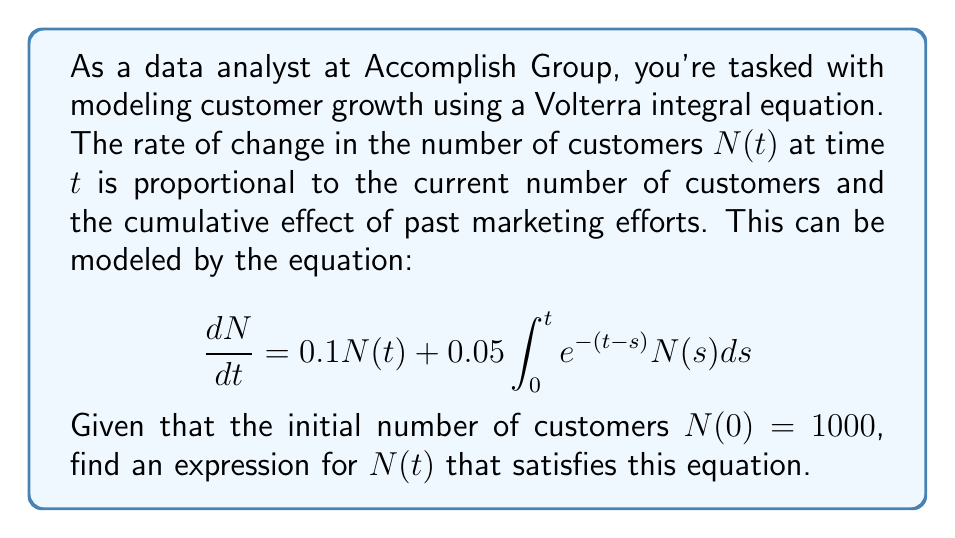Give your solution to this math problem. Let's solve this Volterra integral equation step by step:

1) First, we assume a solution of the form $N(t) = Ae^{\lambda t}$, where $A$ and $\lambda$ are constants to be determined.

2) Substituting this into the left side of the equation:
   $$\frac{dN}{dt} = A\lambda e^{\lambda t}$$

3) For the right side, we need to evaluate the integral:
   $$0.1Ae^{\lambda t} + 0.05\int_0^t e^{-(t-s)}Ae^{\lambda s}ds$$

4) Simplifying the integral:
   $$0.1Ae^{\lambda t} + 0.05A\int_0^t e^{-t+s+\lambda s}ds$$
   $$= 0.1Ae^{\lambda t} + 0.05Ae^{-t}\int_0^t e^{(1+\lambda)s}ds$$

5) Evaluating the integral:
   $$= 0.1Ae^{\lambda t} + 0.05Ae^{-t}\left[\frac{e^{(1+\lambda)s}}{1+\lambda}\right]_0^t$$
   $$= 0.1Ae^{\lambda t} + 0.05Ae^{-t}\left(\frac{e^{(1+\lambda)t}-1}{1+\lambda}\right)$$
   $$= 0.1Ae^{\lambda t} + 0.05A\left(\frac{e^{\lambda t}-e^{-t}}{1+\lambda}\right)$$

6) Equating the left and right sides:
   $$A\lambda e^{\lambda t} = 0.1Ae^{\lambda t} + 0.05A\left(\frac{e^{\lambda t}-e^{-t}}{1+\lambda}\right)$$

7) For this to be true for all $t$, the coefficients of $e^{\lambda t}$ must be equal:
   $$\lambda = 0.1 + \frac{0.05}{1+\lambda}$$

8) Solving this equation:
   $$\lambda^2 + 0.9\lambda - 0.05 = 0$$
   $$\lambda = \frac{-0.9 + \sqrt{0.81 + 0.2}}{2} \approx 0.1$$

9) Using the initial condition $N(0) = 1000$:
   $$1000 = Ae^0 = A$$

Therefore, the solution is $N(t) = 1000e^{0.1t}$.
Answer: $N(t) = 1000e^{0.1t}$ 